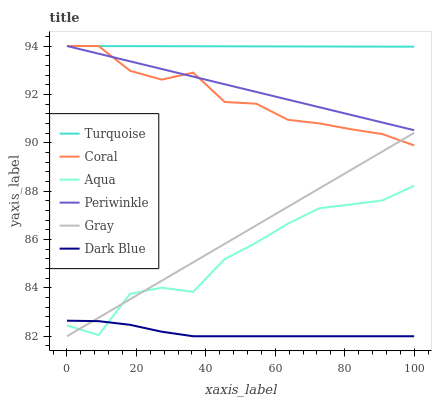Does Dark Blue have the minimum area under the curve?
Answer yes or no. Yes. Does Turquoise have the maximum area under the curve?
Answer yes or no. Yes. Does Coral have the minimum area under the curve?
Answer yes or no. No. Does Coral have the maximum area under the curve?
Answer yes or no. No. Is Periwinkle the smoothest?
Answer yes or no. Yes. Is Aqua the roughest?
Answer yes or no. Yes. Is Turquoise the smoothest?
Answer yes or no. No. Is Turquoise the roughest?
Answer yes or no. No. Does Coral have the lowest value?
Answer yes or no. No. Does Aqua have the highest value?
Answer yes or no. No. Is Aqua less than Coral?
Answer yes or no. Yes. Is Periwinkle greater than Aqua?
Answer yes or no. Yes. Does Aqua intersect Coral?
Answer yes or no. No. 